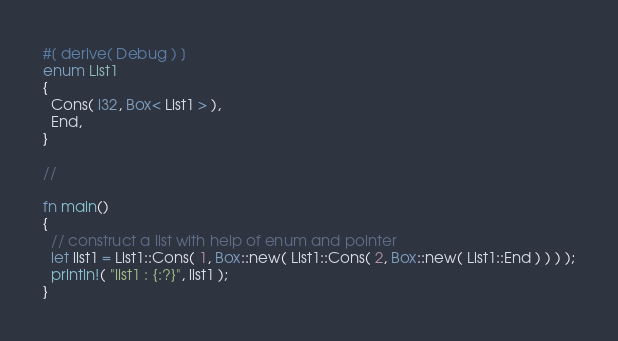<code> <loc_0><loc_0><loc_500><loc_500><_Rust_>
#[ derive( Debug ) ]
enum List1
{
  Cons( i32, Box< List1 > ),
  End,
}

//

fn main()
{
  // construct a list with help of enum and pointer
  let list1 = List1::Cons( 1, Box::new( List1::Cons( 2, Box::new( List1::End ) ) ) );
  println!( "list1 : {:?}", list1 );
}
</code> 